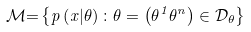Convert formula to latex. <formula><loc_0><loc_0><loc_500><loc_500>\mathcal { M } { = } \left \{ p \left ( x | \theta \right ) \colon \theta = \left ( \theta ^ { 1 } \theta ^ { n } \right ) \in \mathcal { D } _ { \theta } \right \}</formula> 